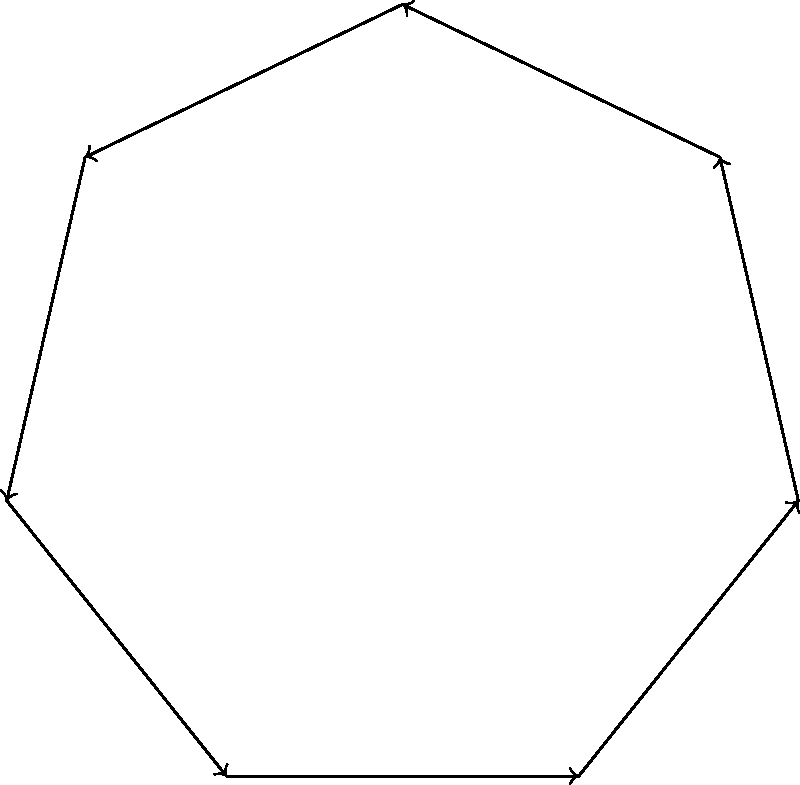As part of a new educational reform to enhance geometric understanding, you're reviewing a lesson plan on regular polygons. The diagram shows a regular heptagon with its center O. If $\alpha$ represents the central angle subtended by one side of the heptagon, what is the measure of one exterior angle of this polygon in terms of $\alpha$? Let's approach this step-by-step:

1) In a regular polygon with $n$ sides:
   - The sum of interior angles = $(n-2) \times 180°$
   - Each interior angle = $\frac{(n-2) \times 180°}{n}$

2) For a heptagon, $n = 7$, so each interior angle = $\frac{(7-2) \times 180°}{7} = \frac{900°}{7}$

3) An exterior angle and its corresponding interior angle are supplementary, meaning they sum to 180°. So:
   Exterior angle = $180° - \text{Interior angle} = 180° - \frac{900°}{7} = \frac{360°}{7}$

4) Now, let's consider the central angle $\alpha$. In a regular polygon, the central angle is given by $\frac{360°}{n}$

5) For our heptagon, $\alpha = \frac{360°}{7}$

6) We can see that the measure of the exterior angle is exactly equal to $\alpha$

Therefore, the measure of one exterior angle of this regular heptagon is equal to $\alpha$.
Answer: $\alpha$ 